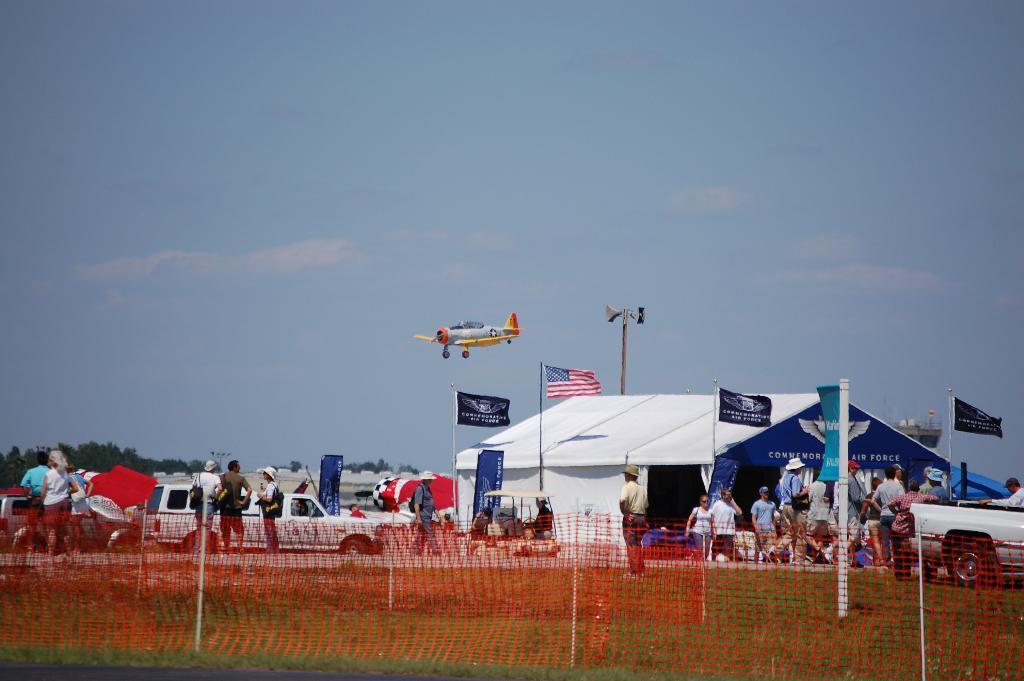In one or two sentences, can you explain what this image depicts? In this image we can see there are people and vehicles on the ground and there is a shed, around the shed there are flags. And there is a net, grass, aircraft and the sky. 